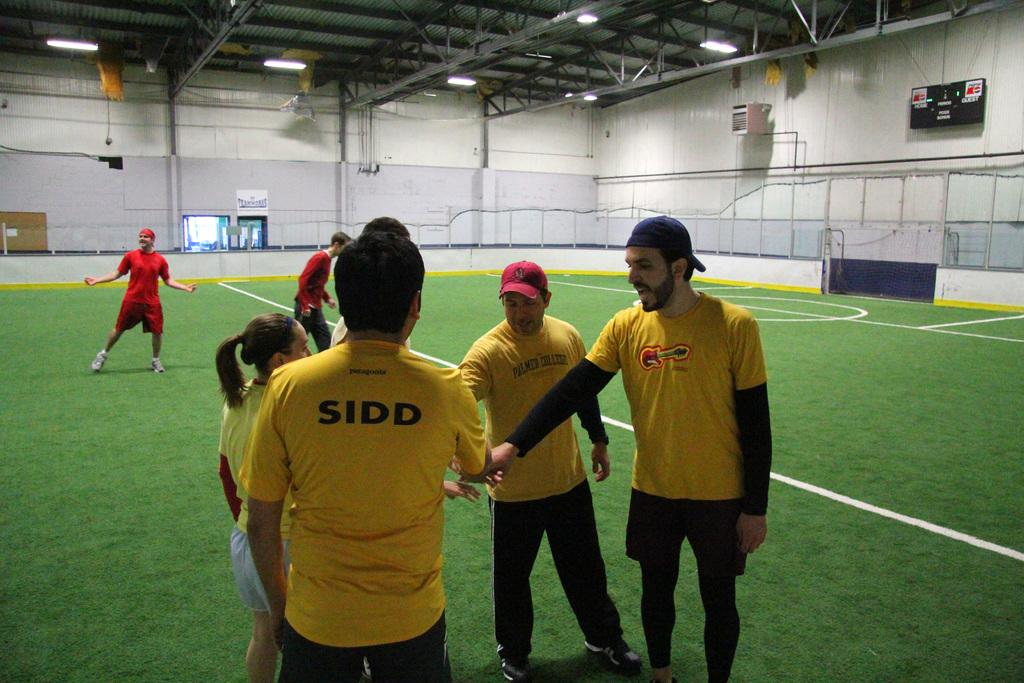<image>
Describe the image concisely. A team of sports players coming together to cheer the other team. 